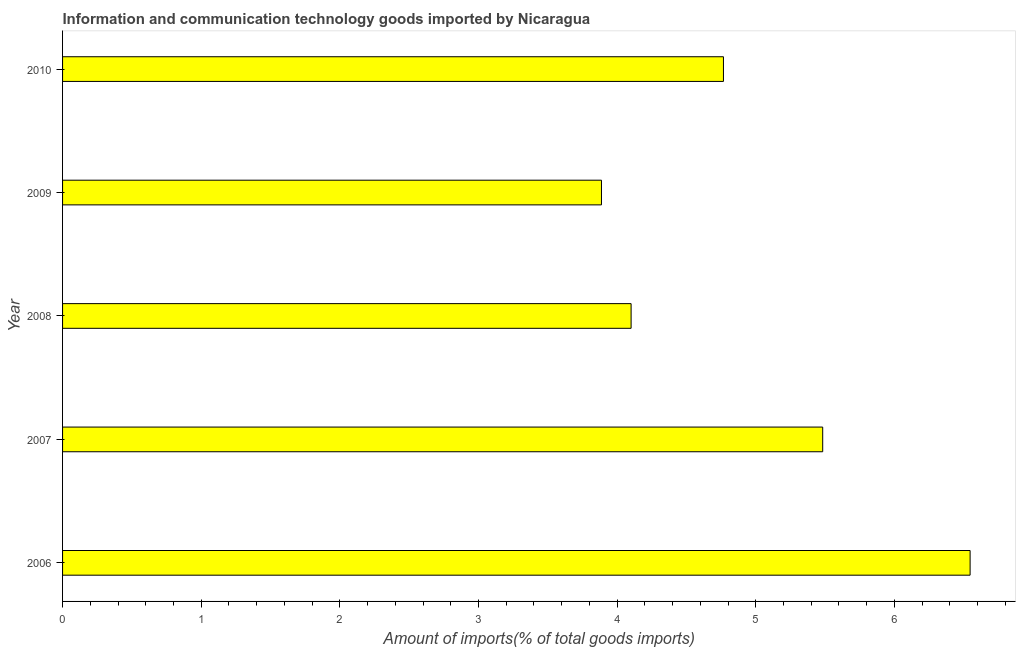Does the graph contain any zero values?
Ensure brevity in your answer.  No. Does the graph contain grids?
Provide a succinct answer. No. What is the title of the graph?
Give a very brief answer. Information and communication technology goods imported by Nicaragua. What is the label or title of the X-axis?
Offer a very short reply. Amount of imports(% of total goods imports). What is the amount of ict goods imports in 2010?
Make the answer very short. 4.77. Across all years, what is the maximum amount of ict goods imports?
Provide a succinct answer. 6.55. Across all years, what is the minimum amount of ict goods imports?
Offer a very short reply. 3.89. In which year was the amount of ict goods imports maximum?
Provide a succinct answer. 2006. In which year was the amount of ict goods imports minimum?
Offer a terse response. 2009. What is the sum of the amount of ict goods imports?
Offer a terse response. 24.78. What is the difference between the amount of ict goods imports in 2006 and 2007?
Ensure brevity in your answer.  1.06. What is the average amount of ict goods imports per year?
Your response must be concise. 4.96. What is the median amount of ict goods imports?
Ensure brevity in your answer.  4.77. In how many years, is the amount of ict goods imports greater than 4.4 %?
Offer a very short reply. 3. Do a majority of the years between 2009 and 2007 (inclusive) have amount of ict goods imports greater than 5.4 %?
Offer a terse response. Yes. What is the ratio of the amount of ict goods imports in 2009 to that in 2010?
Offer a terse response. 0.81. Is the amount of ict goods imports in 2007 less than that in 2008?
Provide a short and direct response. No. Is the difference between the amount of ict goods imports in 2006 and 2009 greater than the difference between any two years?
Provide a succinct answer. Yes. What is the difference between the highest and the second highest amount of ict goods imports?
Your answer should be compact. 1.06. Is the sum of the amount of ict goods imports in 2008 and 2009 greater than the maximum amount of ict goods imports across all years?
Your answer should be very brief. Yes. What is the difference between the highest and the lowest amount of ict goods imports?
Your response must be concise. 2.66. In how many years, is the amount of ict goods imports greater than the average amount of ict goods imports taken over all years?
Offer a terse response. 2. How many years are there in the graph?
Your response must be concise. 5. Are the values on the major ticks of X-axis written in scientific E-notation?
Your answer should be compact. No. What is the Amount of imports(% of total goods imports) of 2006?
Offer a very short reply. 6.55. What is the Amount of imports(% of total goods imports) in 2007?
Ensure brevity in your answer.  5.48. What is the Amount of imports(% of total goods imports) of 2008?
Offer a very short reply. 4.1. What is the Amount of imports(% of total goods imports) in 2009?
Make the answer very short. 3.89. What is the Amount of imports(% of total goods imports) of 2010?
Make the answer very short. 4.77. What is the difference between the Amount of imports(% of total goods imports) in 2006 and 2007?
Give a very brief answer. 1.06. What is the difference between the Amount of imports(% of total goods imports) in 2006 and 2008?
Offer a very short reply. 2.45. What is the difference between the Amount of imports(% of total goods imports) in 2006 and 2009?
Keep it short and to the point. 2.66. What is the difference between the Amount of imports(% of total goods imports) in 2006 and 2010?
Give a very brief answer. 1.78. What is the difference between the Amount of imports(% of total goods imports) in 2007 and 2008?
Provide a short and direct response. 1.38. What is the difference between the Amount of imports(% of total goods imports) in 2007 and 2009?
Your response must be concise. 1.6. What is the difference between the Amount of imports(% of total goods imports) in 2007 and 2010?
Provide a short and direct response. 0.72. What is the difference between the Amount of imports(% of total goods imports) in 2008 and 2009?
Offer a very short reply. 0.21. What is the difference between the Amount of imports(% of total goods imports) in 2008 and 2010?
Give a very brief answer. -0.67. What is the difference between the Amount of imports(% of total goods imports) in 2009 and 2010?
Offer a very short reply. -0.88. What is the ratio of the Amount of imports(% of total goods imports) in 2006 to that in 2007?
Ensure brevity in your answer.  1.19. What is the ratio of the Amount of imports(% of total goods imports) in 2006 to that in 2008?
Provide a succinct answer. 1.6. What is the ratio of the Amount of imports(% of total goods imports) in 2006 to that in 2009?
Ensure brevity in your answer.  1.68. What is the ratio of the Amount of imports(% of total goods imports) in 2006 to that in 2010?
Keep it short and to the point. 1.37. What is the ratio of the Amount of imports(% of total goods imports) in 2007 to that in 2008?
Offer a terse response. 1.34. What is the ratio of the Amount of imports(% of total goods imports) in 2007 to that in 2009?
Your response must be concise. 1.41. What is the ratio of the Amount of imports(% of total goods imports) in 2007 to that in 2010?
Give a very brief answer. 1.15. What is the ratio of the Amount of imports(% of total goods imports) in 2008 to that in 2009?
Give a very brief answer. 1.05. What is the ratio of the Amount of imports(% of total goods imports) in 2008 to that in 2010?
Keep it short and to the point. 0.86. What is the ratio of the Amount of imports(% of total goods imports) in 2009 to that in 2010?
Provide a succinct answer. 0.81. 